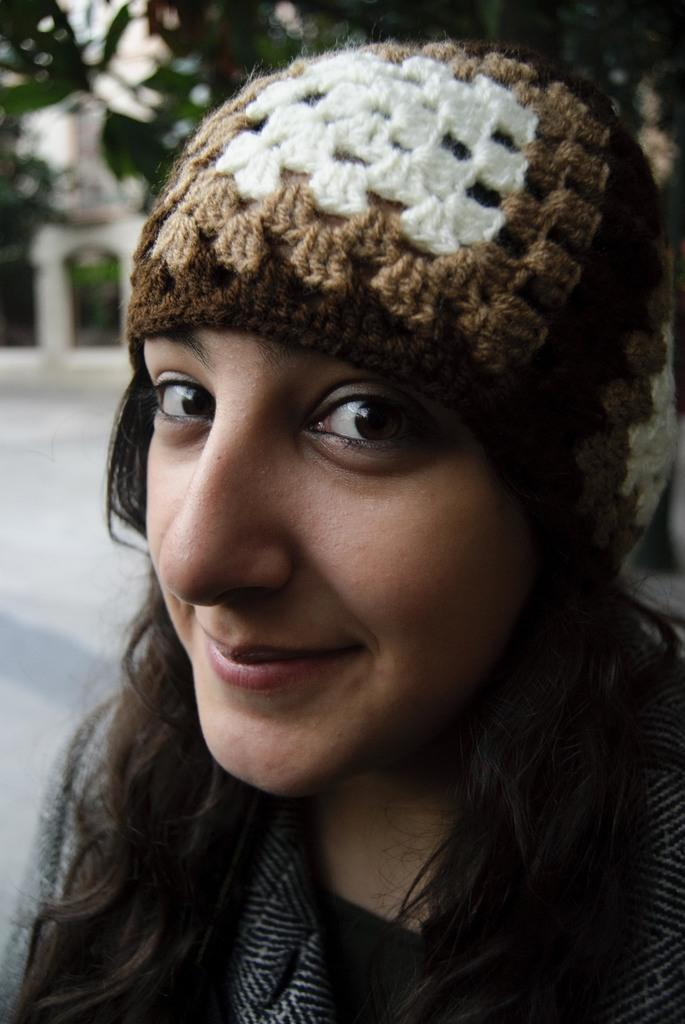Who is present in the image? There is a woman in the image. What is the appearance of the woman's hair? The woman has loose hair. What is the woman's facial expression? The woman is smiling. What can be seen beneath the woman in the image? There is a surface visible in the image. What type of turkey is being bitten by the woman in the image? There is no turkey present in the image, and the woman is not biting anything. What is the woman using to store the jar in the image? There is no jar present in the image. 